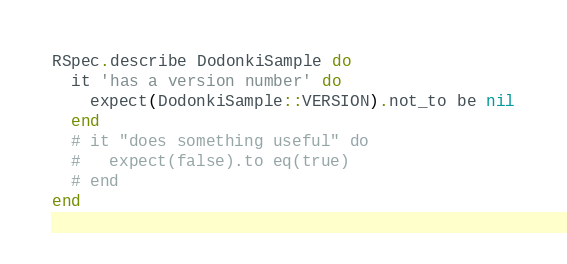Convert code to text. <code><loc_0><loc_0><loc_500><loc_500><_Ruby_>
RSpec.describe DodonkiSample do
  it 'has a version number' do
    expect(DodonkiSample::VERSION).not_to be nil
  end
  # it "does something useful" do
  #   expect(false).to eq(true)
  # end
end
</code> 